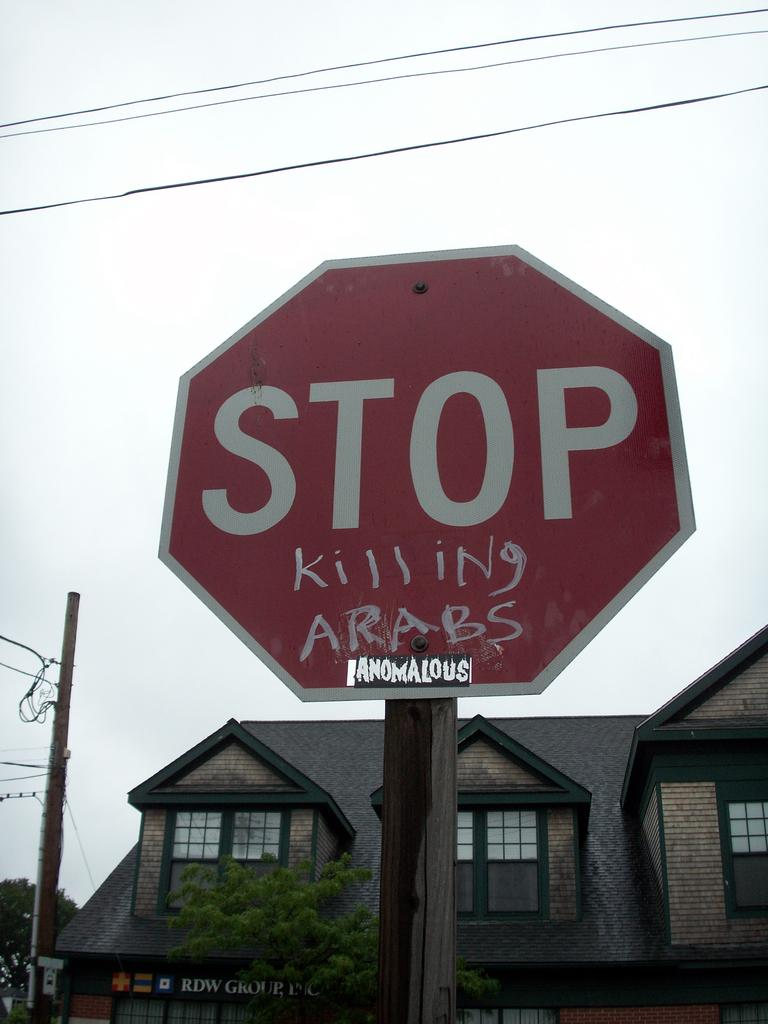<image>
Relay a brief, clear account of the picture shown. A red and white stop sign that has the words killing arabs on the bottom of the sign. 